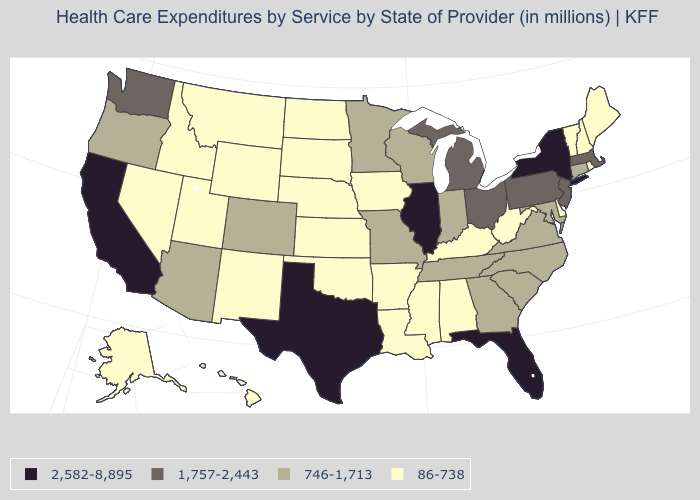What is the lowest value in the USA?
Concise answer only. 86-738. Name the states that have a value in the range 86-738?
Quick response, please. Alabama, Alaska, Arkansas, Delaware, Hawaii, Idaho, Iowa, Kansas, Kentucky, Louisiana, Maine, Mississippi, Montana, Nebraska, Nevada, New Hampshire, New Mexico, North Dakota, Oklahoma, Rhode Island, South Dakota, Utah, Vermont, West Virginia, Wyoming. How many symbols are there in the legend?
Write a very short answer. 4. How many symbols are there in the legend?
Be succinct. 4. Name the states that have a value in the range 1,757-2,443?
Write a very short answer. Massachusetts, Michigan, New Jersey, Ohio, Pennsylvania, Washington. Name the states that have a value in the range 746-1,713?
Short answer required. Arizona, Colorado, Connecticut, Georgia, Indiana, Maryland, Minnesota, Missouri, North Carolina, Oregon, South Carolina, Tennessee, Virginia, Wisconsin. What is the lowest value in the USA?
Short answer required. 86-738. Name the states that have a value in the range 746-1,713?
Concise answer only. Arizona, Colorado, Connecticut, Georgia, Indiana, Maryland, Minnesota, Missouri, North Carolina, Oregon, South Carolina, Tennessee, Virginia, Wisconsin. Name the states that have a value in the range 86-738?
Keep it brief. Alabama, Alaska, Arkansas, Delaware, Hawaii, Idaho, Iowa, Kansas, Kentucky, Louisiana, Maine, Mississippi, Montana, Nebraska, Nevada, New Hampshire, New Mexico, North Dakota, Oklahoma, Rhode Island, South Dakota, Utah, Vermont, West Virginia, Wyoming. What is the value of Virginia?
Write a very short answer. 746-1,713. What is the value of Ohio?
Write a very short answer. 1,757-2,443. Does Tennessee have a lower value than California?
Answer briefly. Yes. Does New York have the highest value in the Northeast?
Be succinct. Yes. What is the value of Arizona?
Write a very short answer. 746-1,713. Among the states that border Pennsylvania , does West Virginia have the lowest value?
Keep it brief. Yes. 